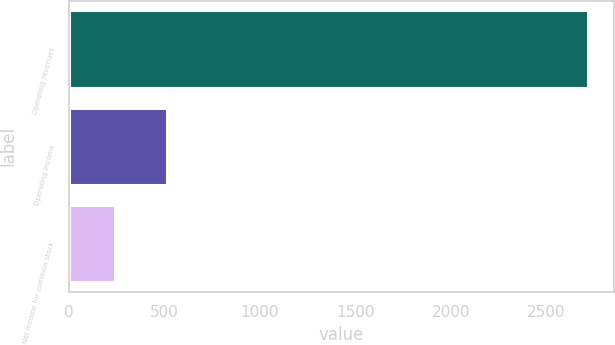<chart> <loc_0><loc_0><loc_500><loc_500><bar_chart><fcel>Operating revenues<fcel>Operating income<fcel>Net income for common stock<nl><fcel>2718<fcel>512<fcel>243<nl></chart> 